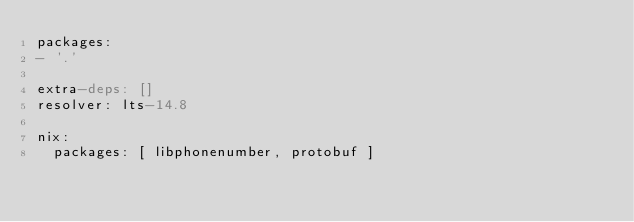Convert code to text. <code><loc_0><loc_0><loc_500><loc_500><_YAML_>packages:
- '.'

extra-deps: []
resolver: lts-14.8

nix:
  packages: [ libphonenumber, protobuf ]
</code> 